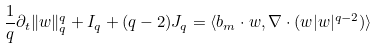<formula> <loc_0><loc_0><loc_500><loc_500>\frac { 1 } { q } \partial _ { t } \| w \| _ { q } ^ { q } + I _ { q } + ( q - 2 ) J _ { q } = \langle b _ { m } \cdot w , \nabla \cdot ( w | w | ^ { q - 2 } ) \rangle</formula> 